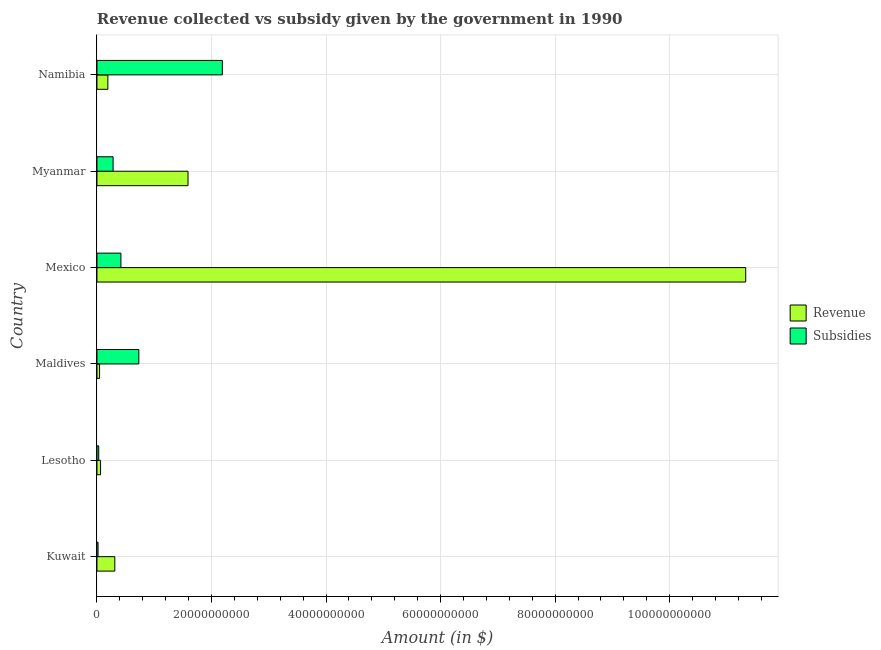How many bars are there on the 5th tick from the bottom?
Offer a very short reply. 2. What is the label of the 4th group of bars from the top?
Ensure brevity in your answer.  Maldives. In how many cases, is the number of bars for a given country not equal to the number of legend labels?
Make the answer very short. 0. What is the amount of subsidies given in Lesotho?
Ensure brevity in your answer.  3.07e+08. Across all countries, what is the maximum amount of revenue collected?
Ensure brevity in your answer.  1.13e+11. Across all countries, what is the minimum amount of revenue collected?
Keep it short and to the point. 4.55e+08. In which country was the amount of subsidies given maximum?
Offer a very short reply. Namibia. In which country was the amount of subsidies given minimum?
Make the answer very short. Kuwait. What is the total amount of revenue collected in the graph?
Give a very brief answer. 1.35e+11. What is the difference between the amount of subsidies given in Kuwait and that in Myanmar?
Your answer should be very brief. -2.63e+09. What is the difference between the amount of revenue collected in Namibia and the amount of subsidies given in Lesotho?
Offer a very short reply. 1.60e+09. What is the average amount of revenue collected per country?
Give a very brief answer. 2.25e+1. What is the difference between the amount of revenue collected and amount of subsidies given in Maldives?
Keep it short and to the point. -6.86e+09. In how many countries, is the amount of subsidies given greater than 100000000000 $?
Keep it short and to the point. 0. What is the ratio of the amount of revenue collected in Lesotho to that in Myanmar?
Ensure brevity in your answer.  0.04. Is the amount of revenue collected in Lesotho less than that in Mexico?
Your answer should be compact. Yes. Is the difference between the amount of subsidies given in Mexico and Myanmar greater than the difference between the amount of revenue collected in Mexico and Myanmar?
Ensure brevity in your answer.  No. What is the difference between the highest and the second highest amount of revenue collected?
Provide a short and direct response. 9.74e+1. What is the difference between the highest and the lowest amount of subsidies given?
Provide a short and direct response. 2.17e+1. What does the 2nd bar from the top in Kuwait represents?
Keep it short and to the point. Revenue. What does the 1st bar from the bottom in Kuwait represents?
Provide a succinct answer. Revenue. How many countries are there in the graph?
Ensure brevity in your answer.  6. What is the difference between two consecutive major ticks on the X-axis?
Make the answer very short. 2.00e+1. Does the graph contain any zero values?
Provide a short and direct response. No. Where does the legend appear in the graph?
Provide a short and direct response. Center right. How many legend labels are there?
Provide a short and direct response. 2. What is the title of the graph?
Provide a succinct answer. Revenue collected vs subsidy given by the government in 1990. What is the label or title of the X-axis?
Offer a very short reply. Amount (in $). What is the Amount (in $) of Revenue in Kuwait?
Keep it short and to the point. 3.12e+09. What is the Amount (in $) in Subsidies in Kuwait?
Provide a succinct answer. 1.88e+08. What is the Amount (in $) of Revenue in Lesotho?
Offer a terse response. 6.28e+08. What is the Amount (in $) of Subsidies in Lesotho?
Provide a short and direct response. 3.07e+08. What is the Amount (in $) of Revenue in Maldives?
Give a very brief answer. 4.55e+08. What is the Amount (in $) in Subsidies in Maldives?
Ensure brevity in your answer.  7.31e+09. What is the Amount (in $) of Revenue in Mexico?
Provide a short and direct response. 1.13e+11. What is the Amount (in $) in Subsidies in Mexico?
Offer a terse response. 4.18e+09. What is the Amount (in $) in Revenue in Myanmar?
Ensure brevity in your answer.  1.59e+1. What is the Amount (in $) of Subsidies in Myanmar?
Provide a succinct answer. 2.82e+09. What is the Amount (in $) in Revenue in Namibia?
Offer a terse response. 1.91e+09. What is the Amount (in $) in Subsidies in Namibia?
Make the answer very short. 2.19e+1. Across all countries, what is the maximum Amount (in $) of Revenue?
Ensure brevity in your answer.  1.13e+11. Across all countries, what is the maximum Amount (in $) of Subsidies?
Offer a terse response. 2.19e+1. Across all countries, what is the minimum Amount (in $) in Revenue?
Your response must be concise. 4.55e+08. Across all countries, what is the minimum Amount (in $) of Subsidies?
Offer a very short reply. 1.88e+08. What is the total Amount (in $) in Revenue in the graph?
Offer a very short reply. 1.35e+11. What is the total Amount (in $) of Subsidies in the graph?
Give a very brief answer. 3.67e+1. What is the difference between the Amount (in $) in Revenue in Kuwait and that in Lesotho?
Offer a very short reply. 2.49e+09. What is the difference between the Amount (in $) in Subsidies in Kuwait and that in Lesotho?
Make the answer very short. -1.19e+08. What is the difference between the Amount (in $) in Revenue in Kuwait and that in Maldives?
Your answer should be very brief. 2.66e+09. What is the difference between the Amount (in $) of Subsidies in Kuwait and that in Maldives?
Ensure brevity in your answer.  -7.12e+09. What is the difference between the Amount (in $) in Revenue in Kuwait and that in Mexico?
Provide a short and direct response. -1.10e+11. What is the difference between the Amount (in $) in Subsidies in Kuwait and that in Mexico?
Ensure brevity in your answer.  -3.99e+09. What is the difference between the Amount (in $) in Revenue in Kuwait and that in Myanmar?
Offer a very short reply. -1.28e+1. What is the difference between the Amount (in $) in Subsidies in Kuwait and that in Myanmar?
Give a very brief answer. -2.63e+09. What is the difference between the Amount (in $) in Revenue in Kuwait and that in Namibia?
Offer a very short reply. 1.21e+09. What is the difference between the Amount (in $) of Subsidies in Kuwait and that in Namibia?
Your answer should be very brief. -2.17e+1. What is the difference between the Amount (in $) in Revenue in Lesotho and that in Maldives?
Your answer should be very brief. 1.73e+08. What is the difference between the Amount (in $) of Subsidies in Lesotho and that in Maldives?
Offer a terse response. -7.00e+09. What is the difference between the Amount (in $) of Revenue in Lesotho and that in Mexico?
Offer a very short reply. -1.13e+11. What is the difference between the Amount (in $) of Subsidies in Lesotho and that in Mexico?
Offer a very short reply. -3.87e+09. What is the difference between the Amount (in $) in Revenue in Lesotho and that in Myanmar?
Keep it short and to the point. -1.53e+1. What is the difference between the Amount (in $) of Subsidies in Lesotho and that in Myanmar?
Keep it short and to the point. -2.51e+09. What is the difference between the Amount (in $) in Revenue in Lesotho and that in Namibia?
Offer a terse response. -1.28e+09. What is the difference between the Amount (in $) in Subsidies in Lesotho and that in Namibia?
Your answer should be very brief. -2.16e+1. What is the difference between the Amount (in $) of Revenue in Maldives and that in Mexico?
Offer a terse response. -1.13e+11. What is the difference between the Amount (in $) of Subsidies in Maldives and that in Mexico?
Keep it short and to the point. 3.13e+09. What is the difference between the Amount (in $) in Revenue in Maldives and that in Myanmar?
Keep it short and to the point. -1.54e+1. What is the difference between the Amount (in $) in Subsidies in Maldives and that in Myanmar?
Give a very brief answer. 4.49e+09. What is the difference between the Amount (in $) of Revenue in Maldives and that in Namibia?
Provide a succinct answer. -1.45e+09. What is the difference between the Amount (in $) of Subsidies in Maldives and that in Namibia?
Ensure brevity in your answer.  -1.46e+1. What is the difference between the Amount (in $) of Revenue in Mexico and that in Myanmar?
Your response must be concise. 9.74e+1. What is the difference between the Amount (in $) in Subsidies in Mexico and that in Myanmar?
Your answer should be compact. 1.36e+09. What is the difference between the Amount (in $) in Revenue in Mexico and that in Namibia?
Ensure brevity in your answer.  1.11e+11. What is the difference between the Amount (in $) of Subsidies in Mexico and that in Namibia?
Your answer should be compact. -1.77e+1. What is the difference between the Amount (in $) of Revenue in Myanmar and that in Namibia?
Provide a succinct answer. 1.40e+1. What is the difference between the Amount (in $) in Subsidies in Myanmar and that in Namibia?
Offer a very short reply. -1.91e+1. What is the difference between the Amount (in $) in Revenue in Kuwait and the Amount (in $) in Subsidies in Lesotho?
Your answer should be compact. 2.81e+09. What is the difference between the Amount (in $) in Revenue in Kuwait and the Amount (in $) in Subsidies in Maldives?
Keep it short and to the point. -4.19e+09. What is the difference between the Amount (in $) of Revenue in Kuwait and the Amount (in $) of Subsidies in Mexico?
Provide a succinct answer. -1.06e+09. What is the difference between the Amount (in $) in Revenue in Kuwait and the Amount (in $) in Subsidies in Myanmar?
Offer a terse response. 3.00e+08. What is the difference between the Amount (in $) of Revenue in Kuwait and the Amount (in $) of Subsidies in Namibia?
Keep it short and to the point. -1.88e+1. What is the difference between the Amount (in $) of Revenue in Lesotho and the Amount (in $) of Subsidies in Maldives?
Your answer should be very brief. -6.68e+09. What is the difference between the Amount (in $) in Revenue in Lesotho and the Amount (in $) in Subsidies in Mexico?
Provide a short and direct response. -3.55e+09. What is the difference between the Amount (in $) of Revenue in Lesotho and the Amount (in $) of Subsidies in Myanmar?
Make the answer very short. -2.19e+09. What is the difference between the Amount (in $) of Revenue in Lesotho and the Amount (in $) of Subsidies in Namibia?
Your answer should be compact. -2.13e+1. What is the difference between the Amount (in $) in Revenue in Maldives and the Amount (in $) in Subsidies in Mexico?
Give a very brief answer. -3.73e+09. What is the difference between the Amount (in $) in Revenue in Maldives and the Amount (in $) in Subsidies in Myanmar?
Offer a very short reply. -2.36e+09. What is the difference between the Amount (in $) in Revenue in Maldives and the Amount (in $) in Subsidies in Namibia?
Offer a very short reply. -2.14e+1. What is the difference between the Amount (in $) of Revenue in Mexico and the Amount (in $) of Subsidies in Myanmar?
Offer a terse response. 1.10e+11. What is the difference between the Amount (in $) in Revenue in Mexico and the Amount (in $) in Subsidies in Namibia?
Keep it short and to the point. 9.14e+1. What is the difference between the Amount (in $) of Revenue in Myanmar and the Amount (in $) of Subsidies in Namibia?
Your response must be concise. -5.99e+09. What is the average Amount (in $) in Revenue per country?
Offer a terse response. 2.25e+1. What is the average Amount (in $) in Subsidies per country?
Your response must be concise. 6.11e+09. What is the difference between the Amount (in $) in Revenue and Amount (in $) in Subsidies in Kuwait?
Your answer should be very brief. 2.93e+09. What is the difference between the Amount (in $) of Revenue and Amount (in $) of Subsidies in Lesotho?
Offer a very short reply. 3.20e+08. What is the difference between the Amount (in $) of Revenue and Amount (in $) of Subsidies in Maldives?
Your answer should be very brief. -6.86e+09. What is the difference between the Amount (in $) of Revenue and Amount (in $) of Subsidies in Mexico?
Offer a terse response. 1.09e+11. What is the difference between the Amount (in $) in Revenue and Amount (in $) in Subsidies in Myanmar?
Your response must be concise. 1.31e+1. What is the difference between the Amount (in $) in Revenue and Amount (in $) in Subsidies in Namibia?
Give a very brief answer. -2.00e+1. What is the ratio of the Amount (in $) of Revenue in Kuwait to that in Lesotho?
Offer a terse response. 4.97. What is the ratio of the Amount (in $) in Subsidies in Kuwait to that in Lesotho?
Give a very brief answer. 0.61. What is the ratio of the Amount (in $) in Revenue in Kuwait to that in Maldives?
Your answer should be compact. 6.85. What is the ratio of the Amount (in $) in Subsidies in Kuwait to that in Maldives?
Keep it short and to the point. 0.03. What is the ratio of the Amount (in $) in Revenue in Kuwait to that in Mexico?
Ensure brevity in your answer.  0.03. What is the ratio of the Amount (in $) of Subsidies in Kuwait to that in Mexico?
Your response must be concise. 0.04. What is the ratio of the Amount (in $) in Revenue in Kuwait to that in Myanmar?
Give a very brief answer. 0.2. What is the ratio of the Amount (in $) in Subsidies in Kuwait to that in Myanmar?
Your response must be concise. 0.07. What is the ratio of the Amount (in $) of Revenue in Kuwait to that in Namibia?
Make the answer very short. 1.63. What is the ratio of the Amount (in $) of Subsidies in Kuwait to that in Namibia?
Give a very brief answer. 0.01. What is the ratio of the Amount (in $) in Revenue in Lesotho to that in Maldives?
Your response must be concise. 1.38. What is the ratio of the Amount (in $) in Subsidies in Lesotho to that in Maldives?
Give a very brief answer. 0.04. What is the ratio of the Amount (in $) in Revenue in Lesotho to that in Mexico?
Your answer should be compact. 0.01. What is the ratio of the Amount (in $) in Subsidies in Lesotho to that in Mexico?
Make the answer very short. 0.07. What is the ratio of the Amount (in $) of Revenue in Lesotho to that in Myanmar?
Keep it short and to the point. 0.04. What is the ratio of the Amount (in $) in Subsidies in Lesotho to that in Myanmar?
Your response must be concise. 0.11. What is the ratio of the Amount (in $) of Revenue in Lesotho to that in Namibia?
Keep it short and to the point. 0.33. What is the ratio of the Amount (in $) in Subsidies in Lesotho to that in Namibia?
Your answer should be very brief. 0.01. What is the ratio of the Amount (in $) of Revenue in Maldives to that in Mexico?
Offer a terse response. 0. What is the ratio of the Amount (in $) of Subsidies in Maldives to that in Mexico?
Your answer should be very brief. 1.75. What is the ratio of the Amount (in $) in Revenue in Maldives to that in Myanmar?
Give a very brief answer. 0.03. What is the ratio of the Amount (in $) of Subsidies in Maldives to that in Myanmar?
Offer a very short reply. 2.6. What is the ratio of the Amount (in $) of Revenue in Maldives to that in Namibia?
Your response must be concise. 0.24. What is the ratio of the Amount (in $) of Subsidies in Maldives to that in Namibia?
Your answer should be very brief. 0.33. What is the ratio of the Amount (in $) of Revenue in Mexico to that in Myanmar?
Offer a very short reply. 7.13. What is the ratio of the Amount (in $) in Subsidies in Mexico to that in Myanmar?
Your answer should be very brief. 1.48. What is the ratio of the Amount (in $) in Revenue in Mexico to that in Namibia?
Give a very brief answer. 59.43. What is the ratio of the Amount (in $) in Subsidies in Mexico to that in Namibia?
Give a very brief answer. 0.19. What is the ratio of the Amount (in $) of Revenue in Myanmar to that in Namibia?
Keep it short and to the point. 8.34. What is the ratio of the Amount (in $) in Subsidies in Myanmar to that in Namibia?
Give a very brief answer. 0.13. What is the difference between the highest and the second highest Amount (in $) in Revenue?
Provide a short and direct response. 9.74e+1. What is the difference between the highest and the second highest Amount (in $) in Subsidies?
Give a very brief answer. 1.46e+1. What is the difference between the highest and the lowest Amount (in $) of Revenue?
Keep it short and to the point. 1.13e+11. What is the difference between the highest and the lowest Amount (in $) in Subsidies?
Provide a short and direct response. 2.17e+1. 